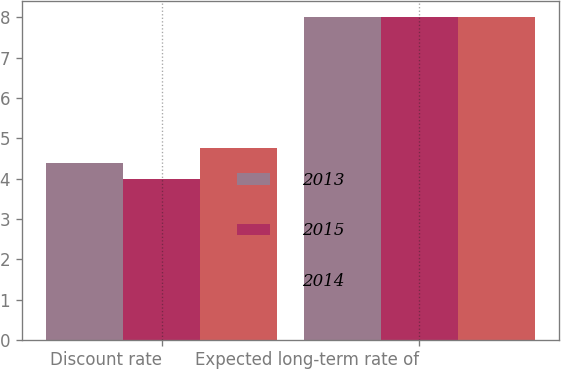Convert chart. <chart><loc_0><loc_0><loc_500><loc_500><stacked_bar_chart><ecel><fcel>Discount rate<fcel>Expected long-term rate of<nl><fcel>2013<fcel>4.38<fcel>8<nl><fcel>2015<fcel>4<fcel>8<nl><fcel>2014<fcel>4.75<fcel>8<nl></chart> 